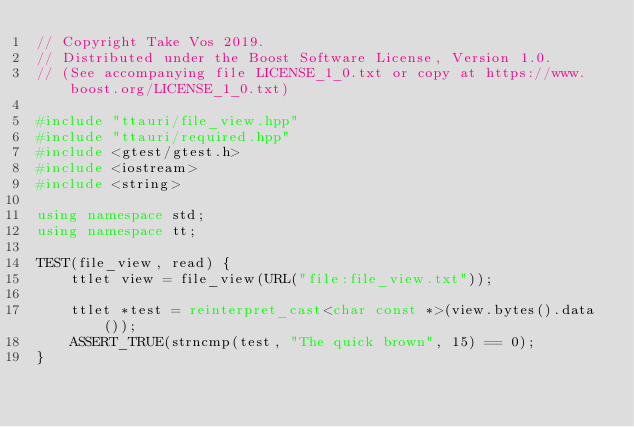Convert code to text. <code><loc_0><loc_0><loc_500><loc_500><_C++_>// Copyright Take Vos 2019.
// Distributed under the Boost Software License, Version 1.0.
// (See accompanying file LICENSE_1_0.txt or copy at https://www.boost.org/LICENSE_1_0.txt)

#include "ttauri/file_view.hpp"
#include "ttauri/required.hpp"
#include <gtest/gtest.h>
#include <iostream>
#include <string>

using namespace std;
using namespace tt;

TEST(file_view, read) {
    ttlet view = file_view(URL("file:file_view.txt"));

    ttlet *test = reinterpret_cast<char const *>(view.bytes().data());
    ASSERT_TRUE(strncmp(test, "The quick brown", 15) == 0);
}
</code> 